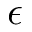Convert formula to latex. <formula><loc_0><loc_0><loc_500><loc_500>\epsilon</formula> 